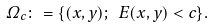<formula> <loc_0><loc_0><loc_500><loc_500>\Omega _ { c } \colon = \{ ( x , y ) ; \ E ( x , y ) < c \} .</formula> 